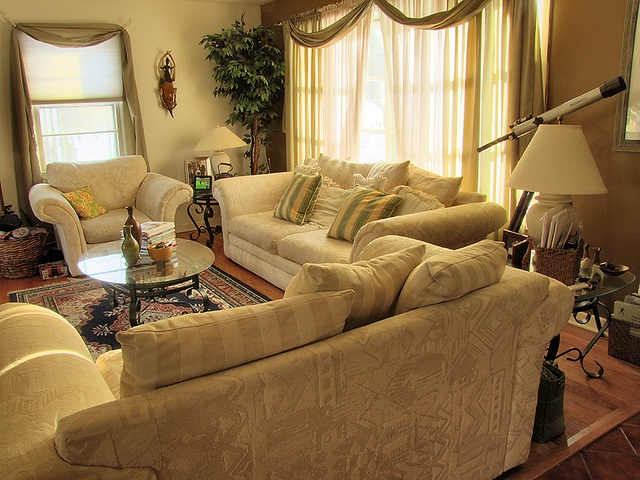Describe the objects in this image and their specific colors. I can see couch in tan, brown, and olive tones, couch in tan and olive tones, chair in tan and olive tones, potted plant in tan, black, olive, and maroon tones, and book in tan and darkgray tones in this image. 